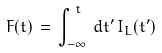<formula> <loc_0><loc_0><loc_500><loc_500>F ( t ) \, = \, \int _ { - \infty } ^ { \, t } \, d t ^ { \prime } \, I _ { L } ( t ^ { \prime } )</formula> 